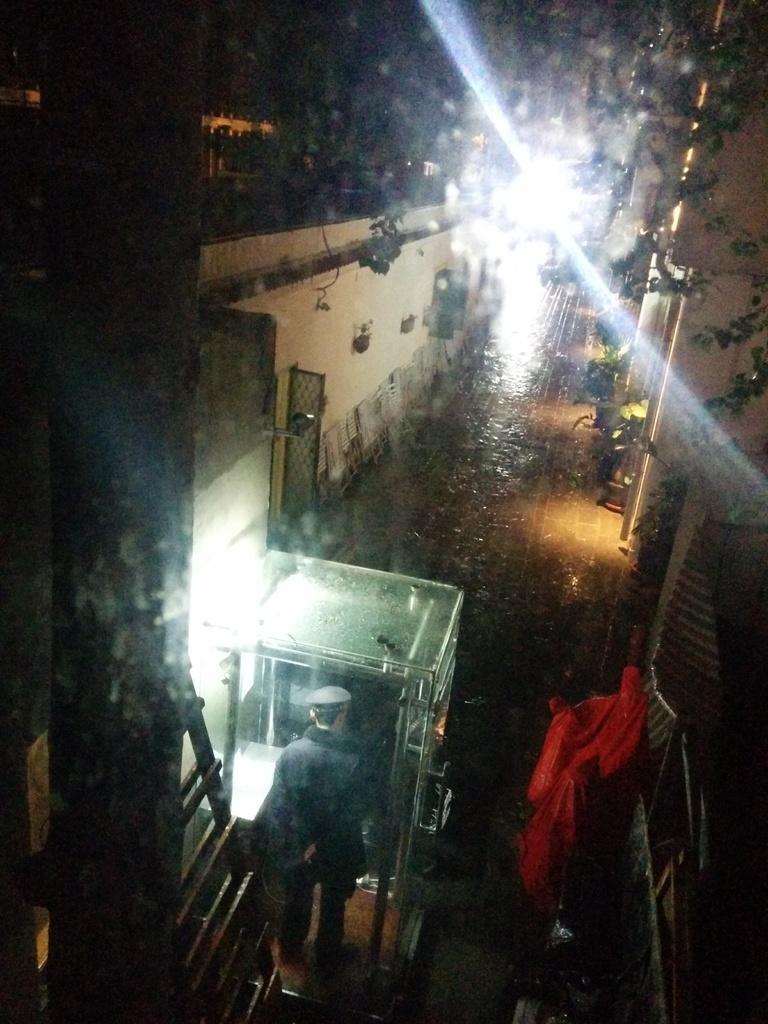Can you describe this image briefly? In this picture, we can see a person, buildings, path, and some objects on the bottom right side of the picture, plants, and lights. 